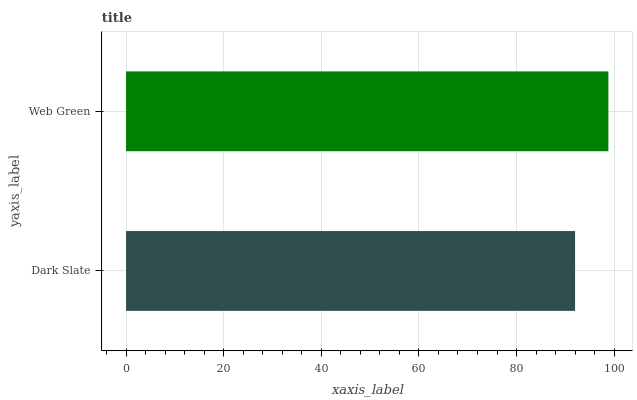Is Dark Slate the minimum?
Answer yes or no. Yes. Is Web Green the maximum?
Answer yes or no. Yes. Is Web Green the minimum?
Answer yes or no. No. Is Web Green greater than Dark Slate?
Answer yes or no. Yes. Is Dark Slate less than Web Green?
Answer yes or no. Yes. Is Dark Slate greater than Web Green?
Answer yes or no. No. Is Web Green less than Dark Slate?
Answer yes or no. No. Is Web Green the high median?
Answer yes or no. Yes. Is Dark Slate the low median?
Answer yes or no. Yes. Is Dark Slate the high median?
Answer yes or no. No. Is Web Green the low median?
Answer yes or no. No. 